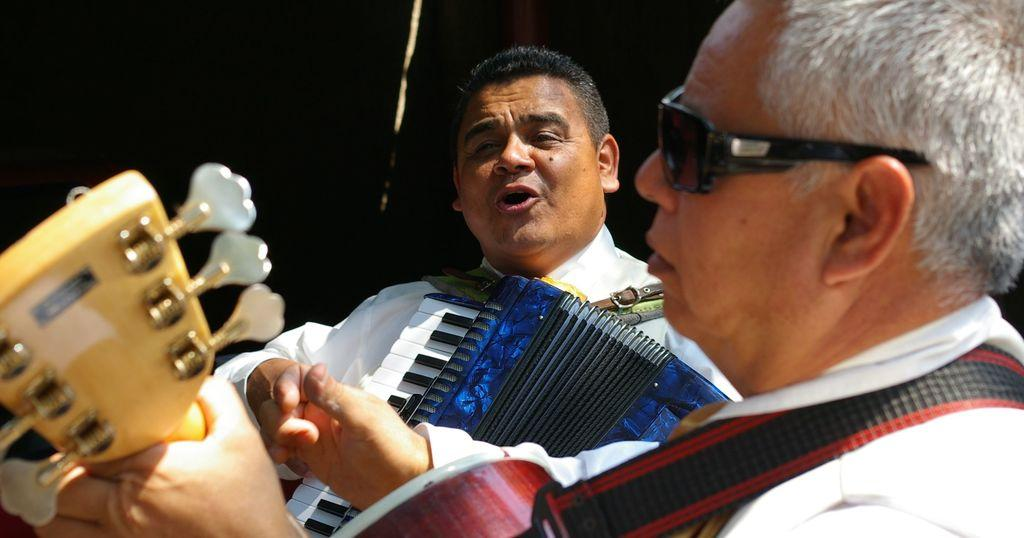How many people are in the image? There are two persons in the image. What are the persons in the image doing? Both persons are holding musical instruments. Can you describe the appearance of the first person? The front person is wearing glasses. What is the second person possibly doing in the image? The second person appears to be singing, as indicated by their facial expression. What type of cattle can be seen grazing in the background of the image? There is no cattle present in the image; it features two persons holding musical instruments. In which direction is the north pole indicated in the image? The image does not contain any reference to the north pole or directions, as it focuses on the two persons with musical instruments. 